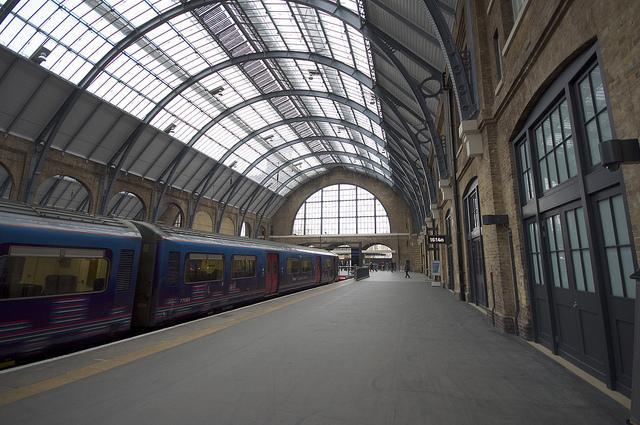What kind of payment is needed for an opportunity to ride this machine?

Choices:
A) donation
B) fare
C) salary payment
D) volunteer payment fare 